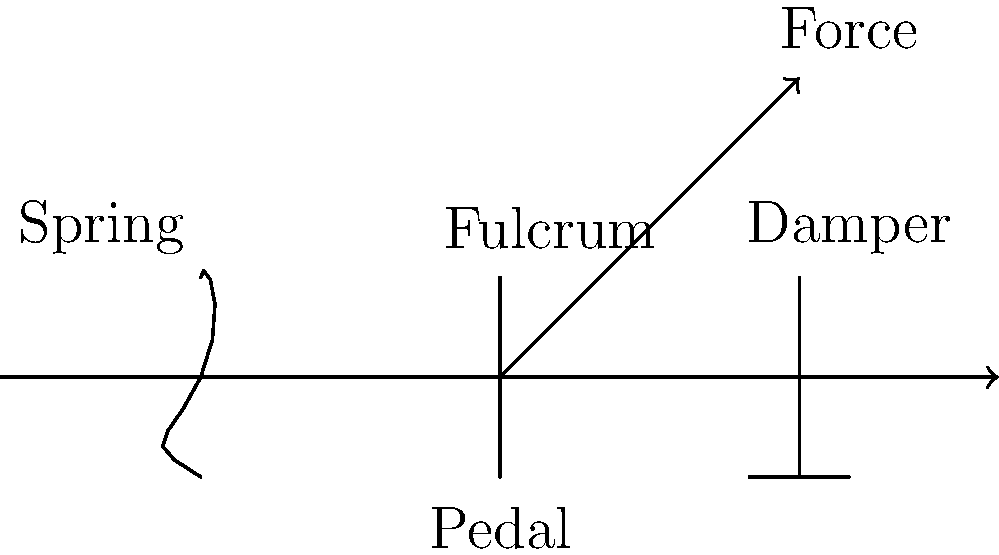In the simplified schematic of a piano pedal system shown above, what is the primary function of the damper component in relation to the pianist's control over the sound? To understand the function of the damper in a piano pedal system, let's break down the components and their roles:

1. Pedal: This is the part the pianist directly interacts with, applying force with their foot.

2. Fulcrum: The pivot point that allows the pedal to move up and down, translating the pianist's foot movement into mechanical action.

3. Spring: Provides resistance and returns the pedal to its resting position when released.

4. Damper: This is the key component for this question.

The damper in a piano serves several crucial functions:

a) Sound control: When the pedal is not pressed, the damper rests against the strings, stopping their vibration and cutting off the sound.

b) Sustain: When the pedal is pressed, the damper lifts off the strings, allowing them to vibrate freely and sustain their sound even after the key is released.

c) Overtone enhancement: With the damper lifted, other strings can vibrate sympathetically, enriching the overall sound.

d) Legato playing: The damper pedal allows notes to blend smoothly, creating a connected, flowing sound.

For a pianist, the damper pedal is a critical tool for expression and control over the piano's sound. It allows for variations in sustain, tonal color, and articulation, which are essential elements in interpreting and performing music.

From a music critic's perspective, the use of the damper pedal can significantly influence the overall performance, affecting factors such as clarity, resonance, and emotional impact of the piece being played.
Answer: Control sustain and resonance of piano strings 